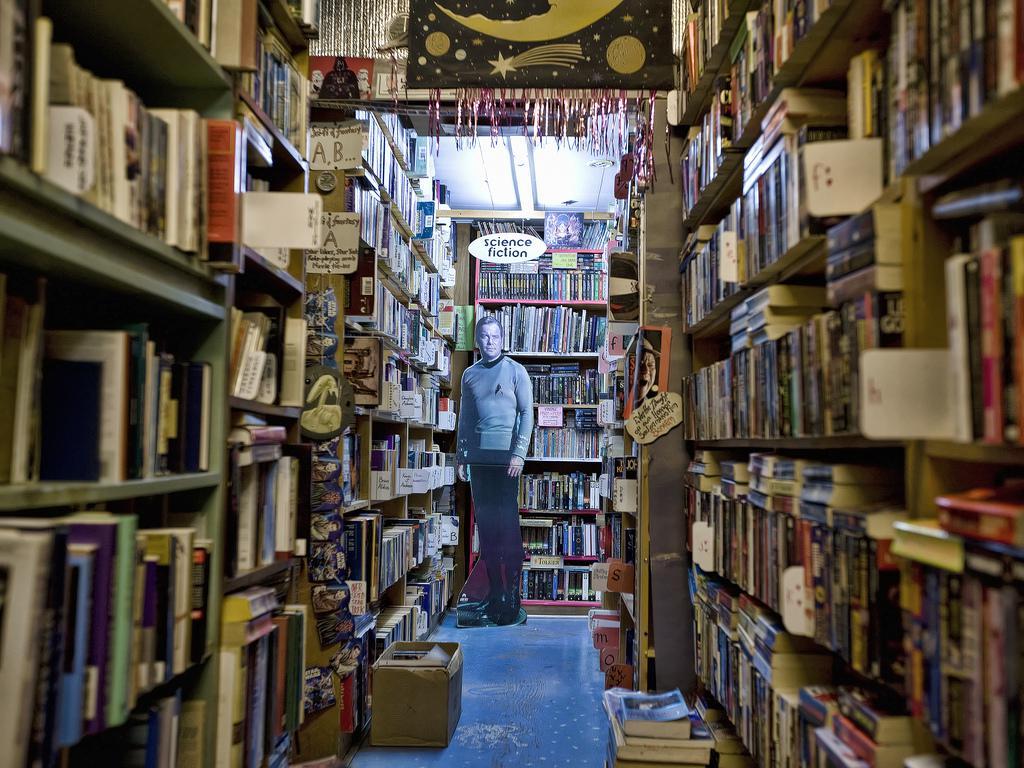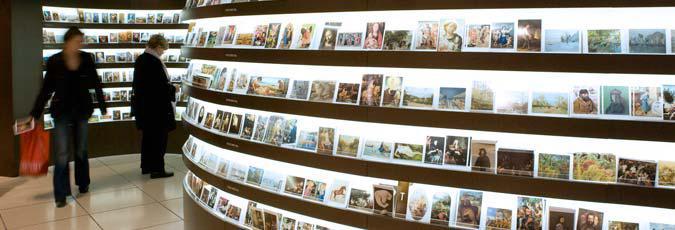The first image is the image on the left, the second image is the image on the right. Examine the images to the left and right. Is the description "There is a storefront in each image." accurate? Answer yes or no. No. The first image is the image on the left, the second image is the image on the right. Analyze the images presented: Is the assertion "At least one person is walking outside of one of the stores." valid? Answer yes or no. No. 